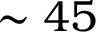Convert formula to latex. <formula><loc_0><loc_0><loc_500><loc_500>\sim 4 5</formula> 